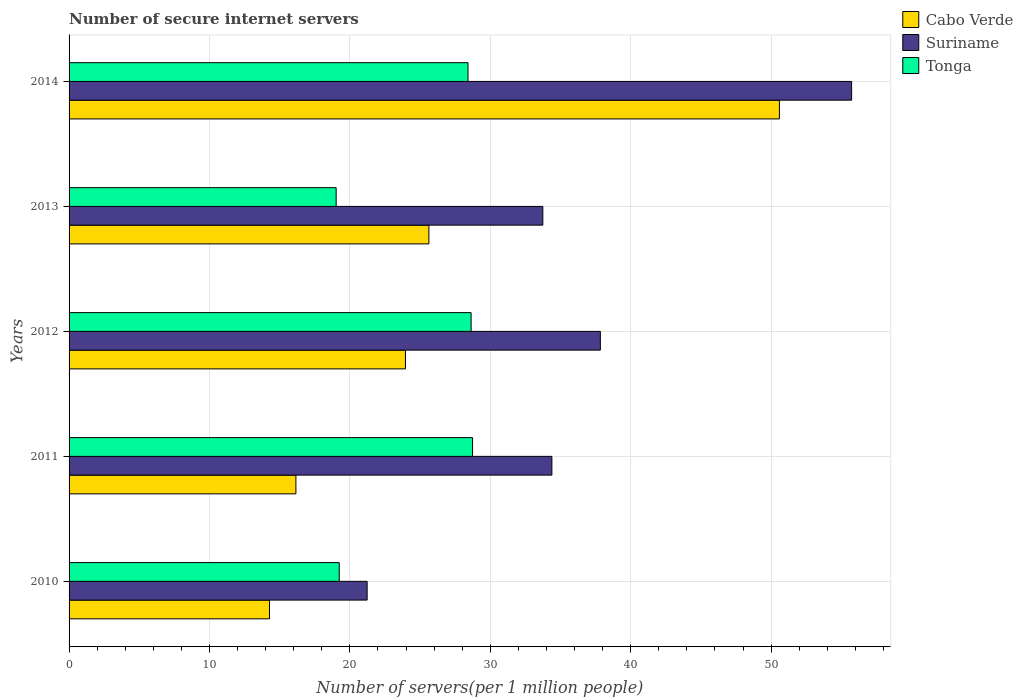How many groups of bars are there?
Provide a short and direct response. 5. Are the number of bars on each tick of the Y-axis equal?
Make the answer very short. Yes. How many bars are there on the 4th tick from the top?
Keep it short and to the point. 3. How many bars are there on the 3rd tick from the bottom?
Ensure brevity in your answer.  3. In how many cases, is the number of bars for a given year not equal to the number of legend labels?
Your answer should be compact. 0. What is the number of secure internet servers in Tonga in 2010?
Give a very brief answer. 19.24. Across all years, what is the maximum number of secure internet servers in Cabo Verde?
Provide a succinct answer. 50.59. Across all years, what is the minimum number of secure internet servers in Suriname?
Keep it short and to the point. 21.23. In which year was the number of secure internet servers in Cabo Verde maximum?
Your answer should be compact. 2014. What is the total number of secure internet servers in Suriname in the graph?
Your answer should be compact. 182.94. What is the difference between the number of secure internet servers in Cabo Verde in 2010 and that in 2012?
Your answer should be compact. -9.68. What is the difference between the number of secure internet servers in Cabo Verde in 2010 and the number of secure internet servers in Tonga in 2012?
Your answer should be compact. -14.36. What is the average number of secure internet servers in Tonga per year?
Keep it short and to the point. 24.81. In the year 2013, what is the difference between the number of secure internet servers in Suriname and number of secure internet servers in Tonga?
Your answer should be very brief. 14.72. In how many years, is the number of secure internet servers in Suriname greater than 12 ?
Give a very brief answer. 5. What is the ratio of the number of secure internet servers in Suriname in 2013 to that in 2014?
Provide a short and direct response. 0.61. Is the difference between the number of secure internet servers in Suriname in 2010 and 2011 greater than the difference between the number of secure internet servers in Tonga in 2010 and 2011?
Offer a very short reply. No. What is the difference between the highest and the second highest number of secure internet servers in Suriname?
Ensure brevity in your answer.  17.9. What is the difference between the highest and the lowest number of secure internet servers in Tonga?
Offer a very short reply. 9.72. In how many years, is the number of secure internet servers in Tonga greater than the average number of secure internet servers in Tonga taken over all years?
Provide a short and direct response. 3. Is the sum of the number of secure internet servers in Suriname in 2010 and 2013 greater than the maximum number of secure internet servers in Tonga across all years?
Give a very brief answer. Yes. What does the 1st bar from the top in 2012 represents?
Offer a very short reply. Tonga. What does the 2nd bar from the bottom in 2013 represents?
Give a very brief answer. Suriname. Is it the case that in every year, the sum of the number of secure internet servers in Suriname and number of secure internet servers in Tonga is greater than the number of secure internet servers in Cabo Verde?
Your answer should be compact. Yes. Are all the bars in the graph horizontal?
Your response must be concise. Yes. Are the values on the major ticks of X-axis written in scientific E-notation?
Ensure brevity in your answer.  No. Does the graph contain any zero values?
Offer a terse response. No. Where does the legend appear in the graph?
Give a very brief answer. Top right. What is the title of the graph?
Your response must be concise. Number of secure internet servers. What is the label or title of the X-axis?
Your answer should be very brief. Number of servers(per 1 million people). What is the label or title of the Y-axis?
Offer a terse response. Years. What is the Number of servers(per 1 million people) in Cabo Verde in 2010?
Ensure brevity in your answer.  14.27. What is the Number of servers(per 1 million people) in Suriname in 2010?
Ensure brevity in your answer.  21.23. What is the Number of servers(per 1 million people) in Tonga in 2010?
Keep it short and to the point. 19.24. What is the Number of servers(per 1 million people) in Cabo Verde in 2011?
Your answer should be very brief. 16.16. What is the Number of servers(per 1 million people) of Suriname in 2011?
Your response must be concise. 34.39. What is the Number of servers(per 1 million people) of Tonga in 2011?
Your answer should be very brief. 28.74. What is the Number of servers(per 1 million people) of Cabo Verde in 2012?
Your answer should be compact. 23.96. What is the Number of servers(per 1 million people) of Suriname in 2012?
Ensure brevity in your answer.  37.84. What is the Number of servers(per 1 million people) of Tonga in 2012?
Your response must be concise. 28.63. What is the Number of servers(per 1 million people) in Cabo Verde in 2013?
Give a very brief answer. 25.63. What is the Number of servers(per 1 million people) in Suriname in 2013?
Offer a very short reply. 33.74. What is the Number of servers(per 1 million people) in Tonga in 2013?
Provide a short and direct response. 19.02. What is the Number of servers(per 1 million people) of Cabo Verde in 2014?
Provide a short and direct response. 50.59. What is the Number of servers(per 1 million people) of Suriname in 2014?
Your answer should be compact. 55.74. What is the Number of servers(per 1 million people) in Tonga in 2014?
Ensure brevity in your answer.  28.41. Across all years, what is the maximum Number of servers(per 1 million people) of Cabo Verde?
Your answer should be compact. 50.59. Across all years, what is the maximum Number of servers(per 1 million people) in Suriname?
Keep it short and to the point. 55.74. Across all years, what is the maximum Number of servers(per 1 million people) in Tonga?
Your answer should be very brief. 28.74. Across all years, what is the minimum Number of servers(per 1 million people) in Cabo Verde?
Provide a short and direct response. 14.27. Across all years, what is the minimum Number of servers(per 1 million people) of Suriname?
Make the answer very short. 21.23. Across all years, what is the minimum Number of servers(per 1 million people) in Tonga?
Ensure brevity in your answer.  19.02. What is the total Number of servers(per 1 million people) of Cabo Verde in the graph?
Make the answer very short. 130.61. What is the total Number of servers(per 1 million people) in Suriname in the graph?
Keep it short and to the point. 182.94. What is the total Number of servers(per 1 million people) in Tonga in the graph?
Your response must be concise. 124.05. What is the difference between the Number of servers(per 1 million people) in Cabo Verde in 2010 and that in 2011?
Your answer should be very brief. -1.88. What is the difference between the Number of servers(per 1 million people) of Suriname in 2010 and that in 2011?
Provide a succinct answer. -13.16. What is the difference between the Number of servers(per 1 million people) of Tonga in 2010 and that in 2011?
Give a very brief answer. -9.5. What is the difference between the Number of servers(per 1 million people) in Cabo Verde in 2010 and that in 2012?
Provide a succinct answer. -9.68. What is the difference between the Number of servers(per 1 million people) of Suriname in 2010 and that in 2012?
Offer a very short reply. -16.61. What is the difference between the Number of servers(per 1 million people) of Tonga in 2010 and that in 2012?
Offer a very short reply. -9.39. What is the difference between the Number of servers(per 1 million people) of Cabo Verde in 2010 and that in 2013?
Your answer should be compact. -11.35. What is the difference between the Number of servers(per 1 million people) in Suriname in 2010 and that in 2013?
Your answer should be very brief. -12.51. What is the difference between the Number of servers(per 1 million people) of Tonga in 2010 and that in 2013?
Make the answer very short. 0.22. What is the difference between the Number of servers(per 1 million people) of Cabo Verde in 2010 and that in 2014?
Your response must be concise. -36.32. What is the difference between the Number of servers(per 1 million people) of Suriname in 2010 and that in 2014?
Keep it short and to the point. -34.51. What is the difference between the Number of servers(per 1 million people) in Tonga in 2010 and that in 2014?
Your answer should be very brief. -9.17. What is the difference between the Number of servers(per 1 million people) in Cabo Verde in 2011 and that in 2012?
Make the answer very short. -7.8. What is the difference between the Number of servers(per 1 million people) of Suriname in 2011 and that in 2012?
Your answer should be compact. -3.45. What is the difference between the Number of servers(per 1 million people) in Tonga in 2011 and that in 2012?
Ensure brevity in your answer.  0.1. What is the difference between the Number of servers(per 1 million people) in Cabo Verde in 2011 and that in 2013?
Offer a very short reply. -9.47. What is the difference between the Number of servers(per 1 million people) in Suriname in 2011 and that in 2013?
Your response must be concise. 0.65. What is the difference between the Number of servers(per 1 million people) in Tonga in 2011 and that in 2013?
Your answer should be very brief. 9.72. What is the difference between the Number of servers(per 1 million people) of Cabo Verde in 2011 and that in 2014?
Ensure brevity in your answer.  -34.44. What is the difference between the Number of servers(per 1 million people) in Suriname in 2011 and that in 2014?
Your response must be concise. -21.35. What is the difference between the Number of servers(per 1 million people) of Tonga in 2011 and that in 2014?
Keep it short and to the point. 0.33. What is the difference between the Number of servers(per 1 million people) of Cabo Verde in 2012 and that in 2013?
Make the answer very short. -1.67. What is the difference between the Number of servers(per 1 million people) of Suriname in 2012 and that in 2013?
Offer a terse response. 4.1. What is the difference between the Number of servers(per 1 million people) in Tonga in 2012 and that in 2013?
Your answer should be very brief. 9.61. What is the difference between the Number of servers(per 1 million people) in Cabo Verde in 2012 and that in 2014?
Give a very brief answer. -26.63. What is the difference between the Number of servers(per 1 million people) in Suriname in 2012 and that in 2014?
Your response must be concise. -17.9. What is the difference between the Number of servers(per 1 million people) of Tonga in 2012 and that in 2014?
Your answer should be very brief. 0.22. What is the difference between the Number of servers(per 1 million people) in Cabo Verde in 2013 and that in 2014?
Your answer should be compact. -24.96. What is the difference between the Number of servers(per 1 million people) in Suriname in 2013 and that in 2014?
Make the answer very short. -21.99. What is the difference between the Number of servers(per 1 million people) in Tonga in 2013 and that in 2014?
Make the answer very short. -9.39. What is the difference between the Number of servers(per 1 million people) of Cabo Verde in 2010 and the Number of servers(per 1 million people) of Suriname in 2011?
Offer a terse response. -20.11. What is the difference between the Number of servers(per 1 million people) of Cabo Verde in 2010 and the Number of servers(per 1 million people) of Tonga in 2011?
Keep it short and to the point. -14.46. What is the difference between the Number of servers(per 1 million people) in Suriname in 2010 and the Number of servers(per 1 million people) in Tonga in 2011?
Keep it short and to the point. -7.51. What is the difference between the Number of servers(per 1 million people) in Cabo Verde in 2010 and the Number of servers(per 1 million people) in Suriname in 2012?
Provide a short and direct response. -23.57. What is the difference between the Number of servers(per 1 million people) of Cabo Verde in 2010 and the Number of servers(per 1 million people) of Tonga in 2012?
Give a very brief answer. -14.36. What is the difference between the Number of servers(per 1 million people) in Suriname in 2010 and the Number of servers(per 1 million people) in Tonga in 2012?
Your answer should be very brief. -7.4. What is the difference between the Number of servers(per 1 million people) of Cabo Verde in 2010 and the Number of servers(per 1 million people) of Suriname in 2013?
Ensure brevity in your answer.  -19.47. What is the difference between the Number of servers(per 1 million people) of Cabo Verde in 2010 and the Number of servers(per 1 million people) of Tonga in 2013?
Keep it short and to the point. -4.75. What is the difference between the Number of servers(per 1 million people) in Suriname in 2010 and the Number of servers(per 1 million people) in Tonga in 2013?
Keep it short and to the point. 2.21. What is the difference between the Number of servers(per 1 million people) in Cabo Verde in 2010 and the Number of servers(per 1 million people) in Suriname in 2014?
Your response must be concise. -41.46. What is the difference between the Number of servers(per 1 million people) of Cabo Verde in 2010 and the Number of servers(per 1 million people) of Tonga in 2014?
Keep it short and to the point. -14.14. What is the difference between the Number of servers(per 1 million people) in Suriname in 2010 and the Number of servers(per 1 million people) in Tonga in 2014?
Provide a short and direct response. -7.18. What is the difference between the Number of servers(per 1 million people) of Cabo Verde in 2011 and the Number of servers(per 1 million people) of Suriname in 2012?
Offer a terse response. -21.68. What is the difference between the Number of servers(per 1 million people) in Cabo Verde in 2011 and the Number of servers(per 1 million people) in Tonga in 2012?
Offer a terse response. -12.48. What is the difference between the Number of servers(per 1 million people) in Suriname in 2011 and the Number of servers(per 1 million people) in Tonga in 2012?
Offer a terse response. 5.75. What is the difference between the Number of servers(per 1 million people) of Cabo Verde in 2011 and the Number of servers(per 1 million people) of Suriname in 2013?
Your response must be concise. -17.59. What is the difference between the Number of servers(per 1 million people) of Cabo Verde in 2011 and the Number of servers(per 1 million people) of Tonga in 2013?
Provide a short and direct response. -2.87. What is the difference between the Number of servers(per 1 million people) in Suriname in 2011 and the Number of servers(per 1 million people) in Tonga in 2013?
Provide a short and direct response. 15.37. What is the difference between the Number of servers(per 1 million people) of Cabo Verde in 2011 and the Number of servers(per 1 million people) of Suriname in 2014?
Your response must be concise. -39.58. What is the difference between the Number of servers(per 1 million people) of Cabo Verde in 2011 and the Number of servers(per 1 million people) of Tonga in 2014?
Your answer should be compact. -12.26. What is the difference between the Number of servers(per 1 million people) in Suriname in 2011 and the Number of servers(per 1 million people) in Tonga in 2014?
Give a very brief answer. 5.98. What is the difference between the Number of servers(per 1 million people) of Cabo Verde in 2012 and the Number of servers(per 1 million people) of Suriname in 2013?
Ensure brevity in your answer.  -9.78. What is the difference between the Number of servers(per 1 million people) of Cabo Verde in 2012 and the Number of servers(per 1 million people) of Tonga in 2013?
Offer a very short reply. 4.94. What is the difference between the Number of servers(per 1 million people) in Suriname in 2012 and the Number of servers(per 1 million people) in Tonga in 2013?
Keep it short and to the point. 18.82. What is the difference between the Number of servers(per 1 million people) of Cabo Verde in 2012 and the Number of servers(per 1 million people) of Suriname in 2014?
Offer a terse response. -31.78. What is the difference between the Number of servers(per 1 million people) of Cabo Verde in 2012 and the Number of servers(per 1 million people) of Tonga in 2014?
Your answer should be very brief. -4.45. What is the difference between the Number of servers(per 1 million people) of Suriname in 2012 and the Number of servers(per 1 million people) of Tonga in 2014?
Your answer should be compact. 9.43. What is the difference between the Number of servers(per 1 million people) in Cabo Verde in 2013 and the Number of servers(per 1 million people) in Suriname in 2014?
Provide a short and direct response. -30.11. What is the difference between the Number of servers(per 1 million people) in Cabo Verde in 2013 and the Number of servers(per 1 million people) in Tonga in 2014?
Provide a short and direct response. -2.78. What is the difference between the Number of servers(per 1 million people) in Suriname in 2013 and the Number of servers(per 1 million people) in Tonga in 2014?
Offer a very short reply. 5.33. What is the average Number of servers(per 1 million people) of Cabo Verde per year?
Keep it short and to the point. 26.12. What is the average Number of servers(per 1 million people) of Suriname per year?
Your response must be concise. 36.59. What is the average Number of servers(per 1 million people) of Tonga per year?
Offer a terse response. 24.81. In the year 2010, what is the difference between the Number of servers(per 1 million people) in Cabo Verde and Number of servers(per 1 million people) in Suriname?
Give a very brief answer. -6.96. In the year 2010, what is the difference between the Number of servers(per 1 million people) of Cabo Verde and Number of servers(per 1 million people) of Tonga?
Provide a succinct answer. -4.97. In the year 2010, what is the difference between the Number of servers(per 1 million people) of Suriname and Number of servers(per 1 million people) of Tonga?
Provide a short and direct response. 1.99. In the year 2011, what is the difference between the Number of servers(per 1 million people) of Cabo Verde and Number of servers(per 1 million people) of Suriname?
Give a very brief answer. -18.23. In the year 2011, what is the difference between the Number of servers(per 1 million people) in Cabo Verde and Number of servers(per 1 million people) in Tonga?
Provide a succinct answer. -12.58. In the year 2011, what is the difference between the Number of servers(per 1 million people) in Suriname and Number of servers(per 1 million people) in Tonga?
Keep it short and to the point. 5.65. In the year 2012, what is the difference between the Number of servers(per 1 million people) in Cabo Verde and Number of servers(per 1 million people) in Suriname?
Your answer should be compact. -13.88. In the year 2012, what is the difference between the Number of servers(per 1 million people) of Cabo Verde and Number of servers(per 1 million people) of Tonga?
Your response must be concise. -4.68. In the year 2012, what is the difference between the Number of servers(per 1 million people) in Suriname and Number of servers(per 1 million people) in Tonga?
Your answer should be compact. 9.21. In the year 2013, what is the difference between the Number of servers(per 1 million people) in Cabo Verde and Number of servers(per 1 million people) in Suriname?
Offer a terse response. -8.11. In the year 2013, what is the difference between the Number of servers(per 1 million people) in Cabo Verde and Number of servers(per 1 million people) in Tonga?
Your answer should be very brief. 6.61. In the year 2013, what is the difference between the Number of servers(per 1 million people) of Suriname and Number of servers(per 1 million people) of Tonga?
Give a very brief answer. 14.72. In the year 2014, what is the difference between the Number of servers(per 1 million people) of Cabo Verde and Number of servers(per 1 million people) of Suriname?
Keep it short and to the point. -5.14. In the year 2014, what is the difference between the Number of servers(per 1 million people) in Cabo Verde and Number of servers(per 1 million people) in Tonga?
Provide a succinct answer. 22.18. In the year 2014, what is the difference between the Number of servers(per 1 million people) of Suriname and Number of servers(per 1 million people) of Tonga?
Your answer should be compact. 27.32. What is the ratio of the Number of servers(per 1 million people) in Cabo Verde in 2010 to that in 2011?
Offer a terse response. 0.88. What is the ratio of the Number of servers(per 1 million people) in Suriname in 2010 to that in 2011?
Ensure brevity in your answer.  0.62. What is the ratio of the Number of servers(per 1 million people) of Tonga in 2010 to that in 2011?
Offer a terse response. 0.67. What is the ratio of the Number of servers(per 1 million people) of Cabo Verde in 2010 to that in 2012?
Give a very brief answer. 0.6. What is the ratio of the Number of servers(per 1 million people) of Suriname in 2010 to that in 2012?
Provide a succinct answer. 0.56. What is the ratio of the Number of servers(per 1 million people) of Tonga in 2010 to that in 2012?
Provide a succinct answer. 0.67. What is the ratio of the Number of servers(per 1 million people) in Cabo Verde in 2010 to that in 2013?
Ensure brevity in your answer.  0.56. What is the ratio of the Number of servers(per 1 million people) of Suriname in 2010 to that in 2013?
Give a very brief answer. 0.63. What is the ratio of the Number of servers(per 1 million people) of Tonga in 2010 to that in 2013?
Ensure brevity in your answer.  1.01. What is the ratio of the Number of servers(per 1 million people) in Cabo Verde in 2010 to that in 2014?
Ensure brevity in your answer.  0.28. What is the ratio of the Number of servers(per 1 million people) of Suriname in 2010 to that in 2014?
Provide a succinct answer. 0.38. What is the ratio of the Number of servers(per 1 million people) of Tonga in 2010 to that in 2014?
Provide a short and direct response. 0.68. What is the ratio of the Number of servers(per 1 million people) of Cabo Verde in 2011 to that in 2012?
Offer a very short reply. 0.67. What is the ratio of the Number of servers(per 1 million people) of Suriname in 2011 to that in 2012?
Provide a succinct answer. 0.91. What is the ratio of the Number of servers(per 1 million people) of Cabo Verde in 2011 to that in 2013?
Offer a very short reply. 0.63. What is the ratio of the Number of servers(per 1 million people) of Suriname in 2011 to that in 2013?
Give a very brief answer. 1.02. What is the ratio of the Number of servers(per 1 million people) of Tonga in 2011 to that in 2013?
Keep it short and to the point. 1.51. What is the ratio of the Number of servers(per 1 million people) in Cabo Verde in 2011 to that in 2014?
Offer a terse response. 0.32. What is the ratio of the Number of servers(per 1 million people) of Suriname in 2011 to that in 2014?
Offer a terse response. 0.62. What is the ratio of the Number of servers(per 1 million people) in Tonga in 2011 to that in 2014?
Your answer should be very brief. 1.01. What is the ratio of the Number of servers(per 1 million people) of Cabo Verde in 2012 to that in 2013?
Your response must be concise. 0.93. What is the ratio of the Number of servers(per 1 million people) of Suriname in 2012 to that in 2013?
Your answer should be very brief. 1.12. What is the ratio of the Number of servers(per 1 million people) in Tonga in 2012 to that in 2013?
Offer a terse response. 1.51. What is the ratio of the Number of servers(per 1 million people) in Cabo Verde in 2012 to that in 2014?
Your answer should be very brief. 0.47. What is the ratio of the Number of servers(per 1 million people) of Suriname in 2012 to that in 2014?
Provide a short and direct response. 0.68. What is the ratio of the Number of servers(per 1 million people) in Tonga in 2012 to that in 2014?
Your response must be concise. 1.01. What is the ratio of the Number of servers(per 1 million people) of Cabo Verde in 2013 to that in 2014?
Provide a short and direct response. 0.51. What is the ratio of the Number of servers(per 1 million people) in Suriname in 2013 to that in 2014?
Keep it short and to the point. 0.61. What is the ratio of the Number of servers(per 1 million people) of Tonga in 2013 to that in 2014?
Your response must be concise. 0.67. What is the difference between the highest and the second highest Number of servers(per 1 million people) in Cabo Verde?
Provide a succinct answer. 24.96. What is the difference between the highest and the second highest Number of servers(per 1 million people) of Suriname?
Make the answer very short. 17.9. What is the difference between the highest and the second highest Number of servers(per 1 million people) of Tonga?
Give a very brief answer. 0.1. What is the difference between the highest and the lowest Number of servers(per 1 million people) in Cabo Verde?
Offer a very short reply. 36.32. What is the difference between the highest and the lowest Number of servers(per 1 million people) of Suriname?
Give a very brief answer. 34.51. What is the difference between the highest and the lowest Number of servers(per 1 million people) in Tonga?
Provide a succinct answer. 9.72. 